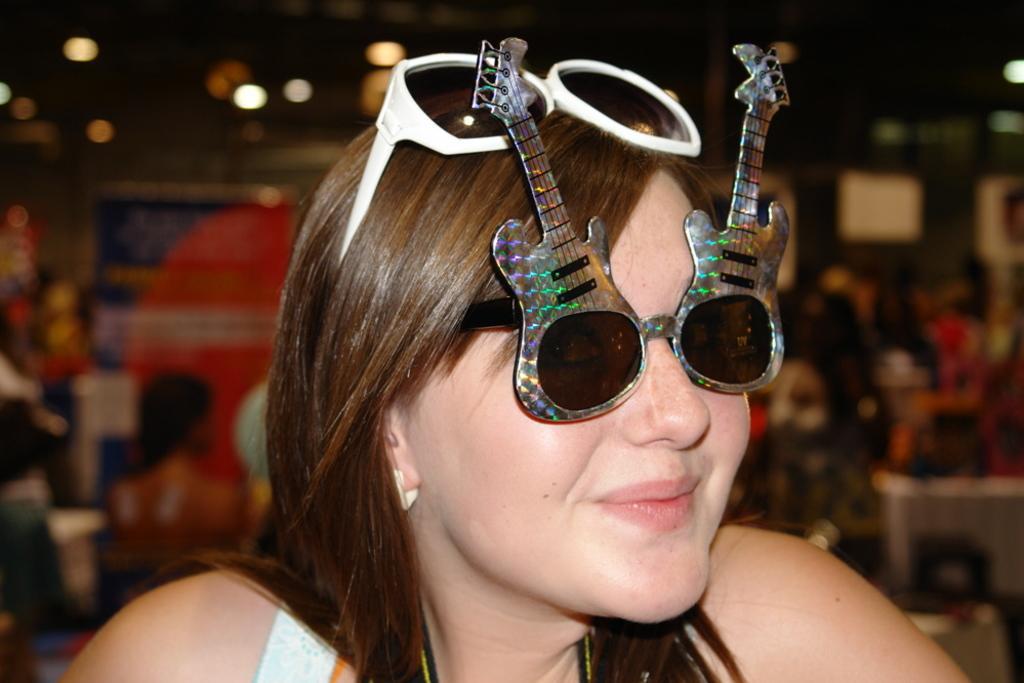Could you give a brief overview of what you see in this image? This picture shows a woman seated with sunglasses on her face and another spectacles on her head and we see smile on her face and few of them seated on the back and we see lights to the roof. 